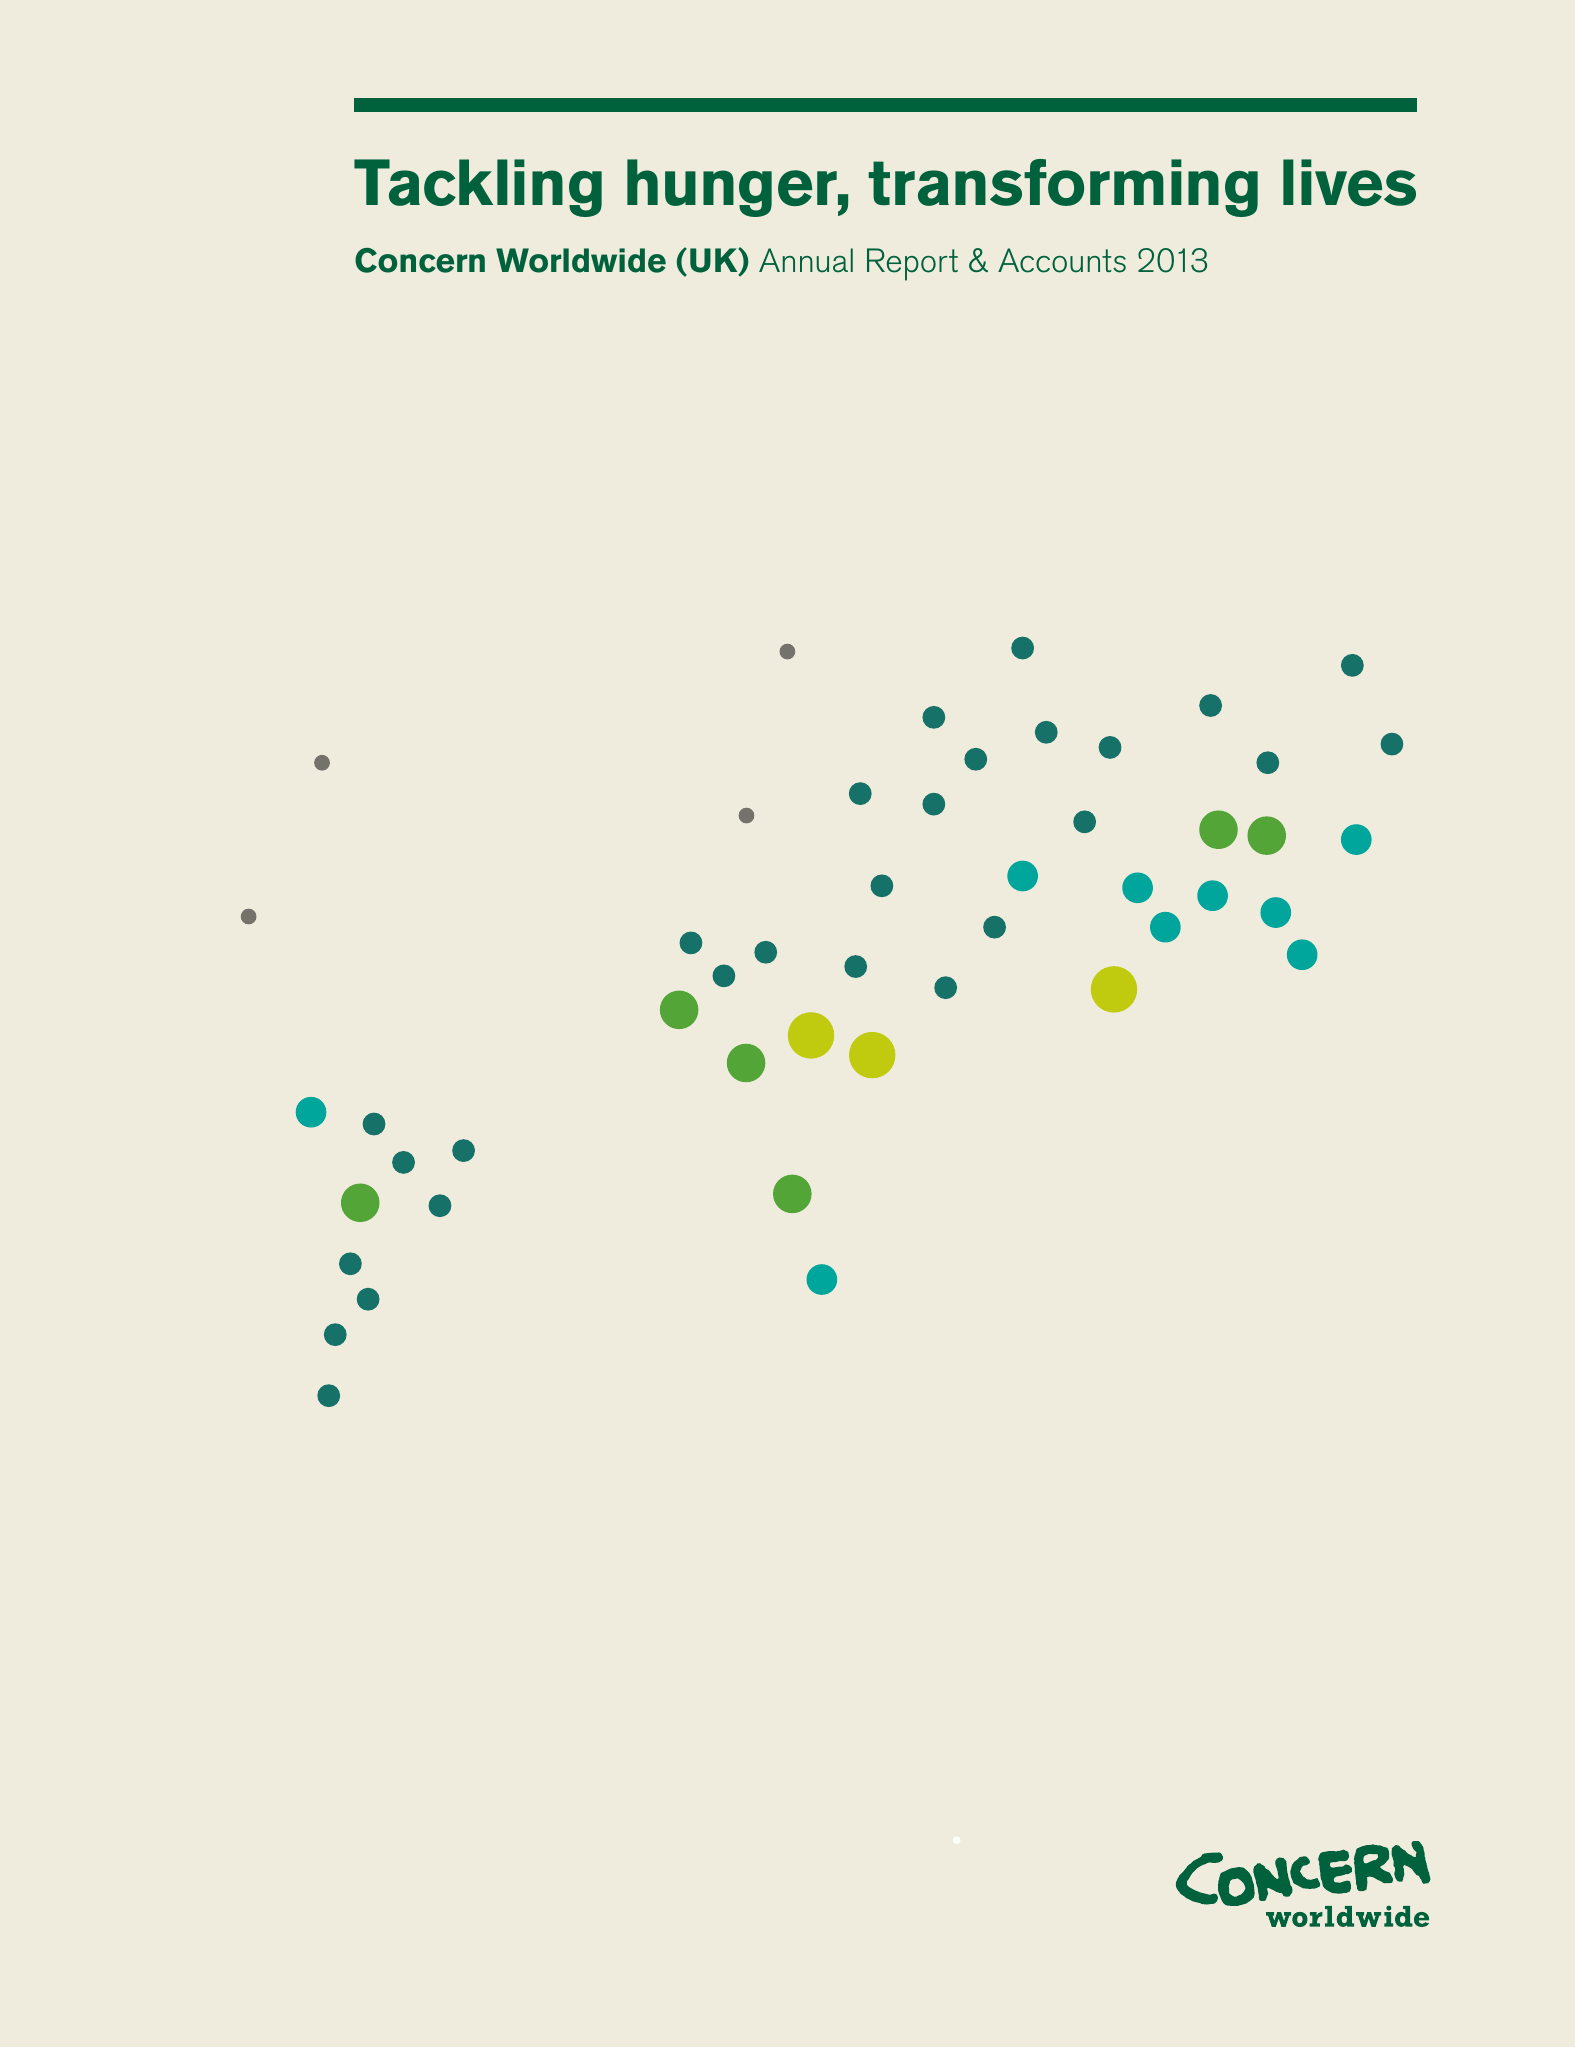What is the value for the spending_annually_in_british_pounds?
Answer the question using a single word or phrase. 16881873.00 